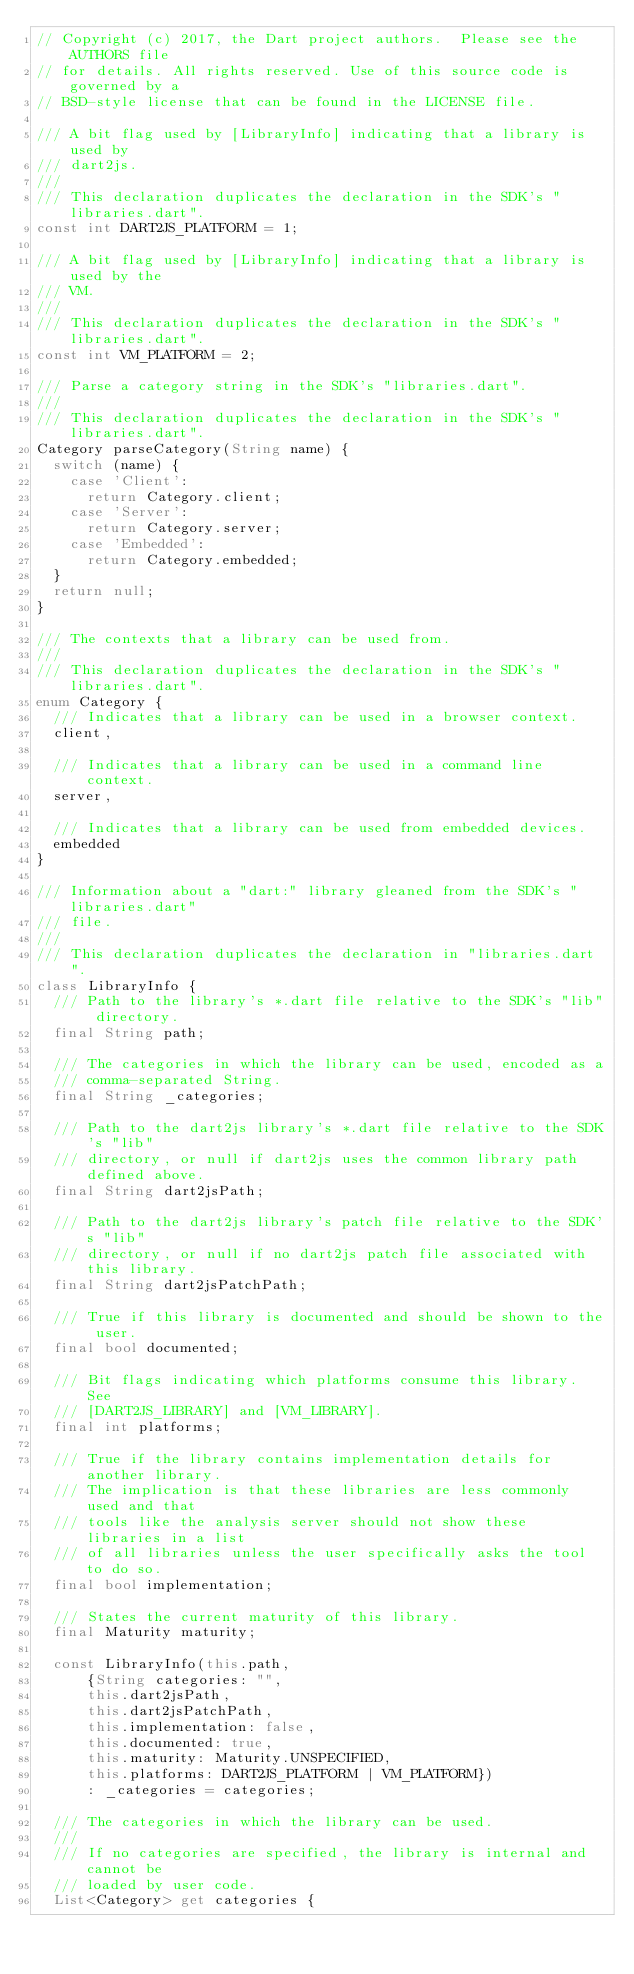<code> <loc_0><loc_0><loc_500><loc_500><_Dart_>// Copyright (c) 2017, the Dart project authors.  Please see the AUTHORS file
// for details. All rights reserved. Use of this source code is governed by a
// BSD-style license that can be found in the LICENSE file.

/// A bit flag used by [LibraryInfo] indicating that a library is used by
/// dart2js.
///
/// This declaration duplicates the declaration in the SDK's "libraries.dart".
const int DART2JS_PLATFORM = 1;

/// A bit flag used by [LibraryInfo] indicating that a library is used by the
/// VM.
///
/// This declaration duplicates the declaration in the SDK's "libraries.dart".
const int VM_PLATFORM = 2;

/// Parse a category string in the SDK's "libraries.dart".
///
/// This declaration duplicates the declaration in the SDK's "libraries.dart".
Category parseCategory(String name) {
  switch (name) {
    case 'Client':
      return Category.client;
    case 'Server':
      return Category.server;
    case 'Embedded':
      return Category.embedded;
  }
  return null;
}

/// The contexts that a library can be used from.
///
/// This declaration duplicates the declaration in the SDK's "libraries.dart".
enum Category {
  /// Indicates that a library can be used in a browser context.
  client,

  /// Indicates that a library can be used in a command line context.
  server,

  /// Indicates that a library can be used from embedded devices.
  embedded
}

/// Information about a "dart:" library gleaned from the SDK's "libraries.dart"
/// file.
///
/// This declaration duplicates the declaration in "libraries.dart".
class LibraryInfo {
  /// Path to the library's *.dart file relative to the SDK's "lib" directory.
  final String path;

  /// The categories in which the library can be used, encoded as a
  /// comma-separated String.
  final String _categories;

  /// Path to the dart2js library's *.dart file relative to the SDK's "lib"
  /// directory, or null if dart2js uses the common library path defined above.
  final String dart2jsPath;

  /// Path to the dart2js library's patch file relative to the SDK's "lib"
  /// directory, or null if no dart2js patch file associated with this library.
  final String dart2jsPatchPath;

  /// True if this library is documented and should be shown to the user.
  final bool documented;

  /// Bit flags indicating which platforms consume this library.  See
  /// [DART2JS_LIBRARY] and [VM_LIBRARY].
  final int platforms;

  /// True if the library contains implementation details for another library.
  /// The implication is that these libraries are less commonly used and that
  /// tools like the analysis server should not show these libraries in a list
  /// of all libraries unless the user specifically asks the tool to do so.
  final bool implementation;

  /// States the current maturity of this library.
  final Maturity maturity;

  const LibraryInfo(this.path,
      {String categories: "",
      this.dart2jsPath,
      this.dart2jsPatchPath,
      this.implementation: false,
      this.documented: true,
      this.maturity: Maturity.UNSPECIFIED,
      this.platforms: DART2JS_PLATFORM | VM_PLATFORM})
      : _categories = categories;

  /// The categories in which the library can be used.
  ///
  /// If no categories are specified, the library is internal and cannot be
  /// loaded by user code.
  List<Category> get categories {</code> 